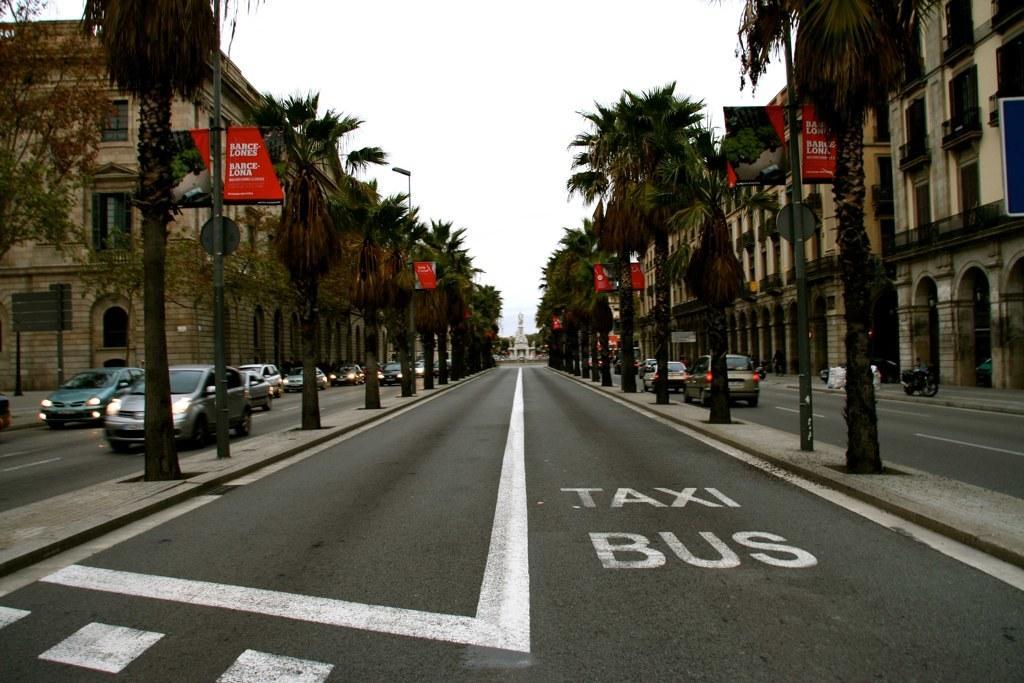Could you give a brief overview of what you see in this image? On the right and left side of the image we can see vehicles, trees and buildings. In the center of the image we can see road and pillar. In the background there is sky. 